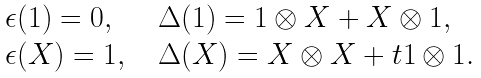<formula> <loc_0><loc_0><loc_500><loc_500>\begin{array} { l l l } \epsilon ( 1 ) = 0 , & & \Delta ( 1 ) = 1 \otimes X + X \otimes 1 , \\ \epsilon ( X ) = 1 , & & \Delta ( X ) = X \otimes X + t 1 \otimes 1 . \end{array}</formula> 